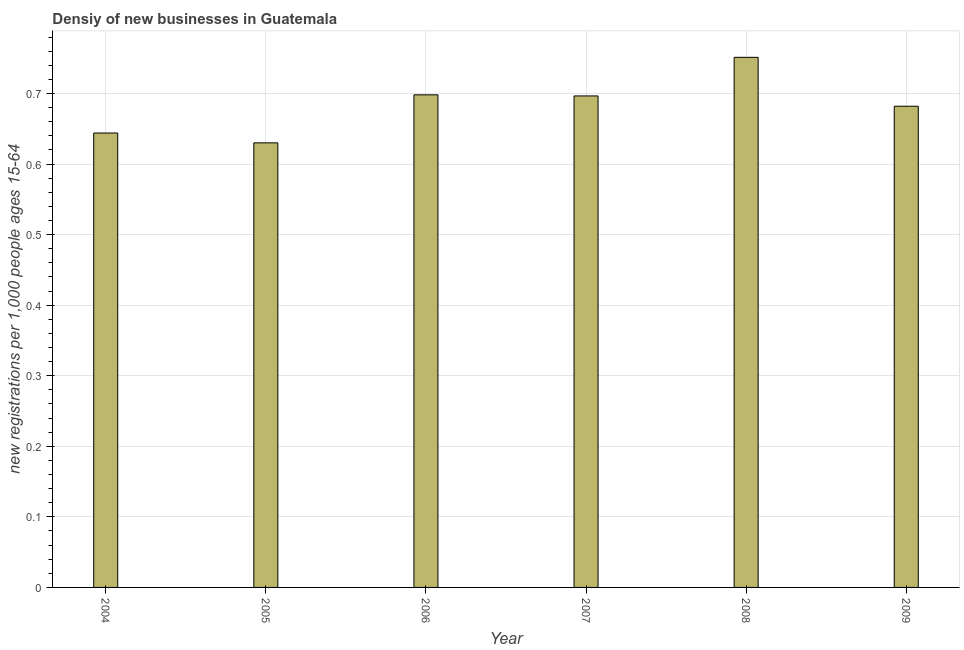Does the graph contain any zero values?
Give a very brief answer. No. What is the title of the graph?
Provide a succinct answer. Densiy of new businesses in Guatemala. What is the label or title of the Y-axis?
Offer a very short reply. New registrations per 1,0 people ages 15-64. What is the density of new business in 2006?
Provide a succinct answer. 0.7. Across all years, what is the maximum density of new business?
Provide a short and direct response. 0.75. Across all years, what is the minimum density of new business?
Your answer should be compact. 0.63. What is the sum of the density of new business?
Provide a succinct answer. 4.1. What is the difference between the density of new business in 2006 and 2008?
Give a very brief answer. -0.05. What is the average density of new business per year?
Give a very brief answer. 0.68. What is the median density of new business?
Keep it short and to the point. 0.69. What is the ratio of the density of new business in 2004 to that in 2008?
Provide a succinct answer. 0.86. Is the difference between the density of new business in 2004 and 2006 greater than the difference between any two years?
Provide a succinct answer. No. What is the difference between the highest and the second highest density of new business?
Provide a succinct answer. 0.05. Is the sum of the density of new business in 2008 and 2009 greater than the maximum density of new business across all years?
Provide a short and direct response. Yes. What is the difference between the highest and the lowest density of new business?
Your answer should be very brief. 0.12. How many years are there in the graph?
Ensure brevity in your answer.  6. What is the difference between two consecutive major ticks on the Y-axis?
Your response must be concise. 0.1. Are the values on the major ticks of Y-axis written in scientific E-notation?
Your answer should be compact. No. What is the new registrations per 1,000 people ages 15-64 in 2004?
Your response must be concise. 0.64. What is the new registrations per 1,000 people ages 15-64 of 2005?
Make the answer very short. 0.63. What is the new registrations per 1,000 people ages 15-64 in 2006?
Give a very brief answer. 0.7. What is the new registrations per 1,000 people ages 15-64 in 2007?
Your response must be concise. 0.7. What is the new registrations per 1,000 people ages 15-64 in 2008?
Offer a terse response. 0.75. What is the new registrations per 1,000 people ages 15-64 in 2009?
Your answer should be compact. 0.68. What is the difference between the new registrations per 1,000 people ages 15-64 in 2004 and 2005?
Provide a short and direct response. 0.01. What is the difference between the new registrations per 1,000 people ages 15-64 in 2004 and 2006?
Make the answer very short. -0.05. What is the difference between the new registrations per 1,000 people ages 15-64 in 2004 and 2007?
Offer a terse response. -0.05. What is the difference between the new registrations per 1,000 people ages 15-64 in 2004 and 2008?
Ensure brevity in your answer.  -0.11. What is the difference between the new registrations per 1,000 people ages 15-64 in 2004 and 2009?
Offer a terse response. -0.04. What is the difference between the new registrations per 1,000 people ages 15-64 in 2005 and 2006?
Make the answer very short. -0.07. What is the difference between the new registrations per 1,000 people ages 15-64 in 2005 and 2007?
Offer a very short reply. -0.07. What is the difference between the new registrations per 1,000 people ages 15-64 in 2005 and 2008?
Give a very brief answer. -0.12. What is the difference between the new registrations per 1,000 people ages 15-64 in 2005 and 2009?
Ensure brevity in your answer.  -0.05. What is the difference between the new registrations per 1,000 people ages 15-64 in 2006 and 2007?
Provide a succinct answer. 0. What is the difference between the new registrations per 1,000 people ages 15-64 in 2006 and 2008?
Provide a succinct answer. -0.05. What is the difference between the new registrations per 1,000 people ages 15-64 in 2006 and 2009?
Give a very brief answer. 0.02. What is the difference between the new registrations per 1,000 people ages 15-64 in 2007 and 2008?
Keep it short and to the point. -0.05. What is the difference between the new registrations per 1,000 people ages 15-64 in 2007 and 2009?
Your answer should be very brief. 0.01. What is the difference between the new registrations per 1,000 people ages 15-64 in 2008 and 2009?
Your answer should be compact. 0.07. What is the ratio of the new registrations per 1,000 people ages 15-64 in 2004 to that in 2006?
Your answer should be very brief. 0.92. What is the ratio of the new registrations per 1,000 people ages 15-64 in 2004 to that in 2007?
Provide a short and direct response. 0.93. What is the ratio of the new registrations per 1,000 people ages 15-64 in 2004 to that in 2008?
Your answer should be compact. 0.86. What is the ratio of the new registrations per 1,000 people ages 15-64 in 2004 to that in 2009?
Offer a very short reply. 0.94. What is the ratio of the new registrations per 1,000 people ages 15-64 in 2005 to that in 2006?
Provide a short and direct response. 0.9. What is the ratio of the new registrations per 1,000 people ages 15-64 in 2005 to that in 2007?
Provide a short and direct response. 0.91. What is the ratio of the new registrations per 1,000 people ages 15-64 in 2005 to that in 2008?
Make the answer very short. 0.84. What is the ratio of the new registrations per 1,000 people ages 15-64 in 2005 to that in 2009?
Your answer should be compact. 0.92. What is the ratio of the new registrations per 1,000 people ages 15-64 in 2006 to that in 2008?
Provide a short and direct response. 0.93. What is the ratio of the new registrations per 1,000 people ages 15-64 in 2007 to that in 2008?
Your response must be concise. 0.93. What is the ratio of the new registrations per 1,000 people ages 15-64 in 2008 to that in 2009?
Your answer should be compact. 1.1. 